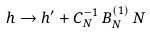Convert formula to latex. <formula><loc_0><loc_0><loc_500><loc_500>h \rightarrow h ^ { \prime } + { C } _ { N } ^ { - 1 } \, { B } _ { N } ^ { ( 1 ) } \, N</formula> 